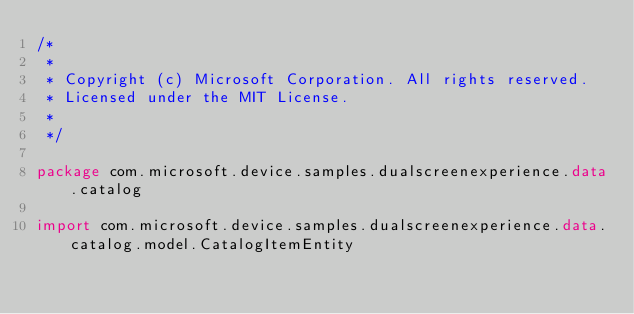Convert code to text. <code><loc_0><loc_0><loc_500><loc_500><_Kotlin_>/*
 *
 * Copyright (c) Microsoft Corporation. All rights reserved.
 * Licensed under the MIT License.
 *
 */

package com.microsoft.device.samples.dualscreenexperience.data.catalog

import com.microsoft.device.samples.dualscreenexperience.data.catalog.model.CatalogItemEntity</code> 